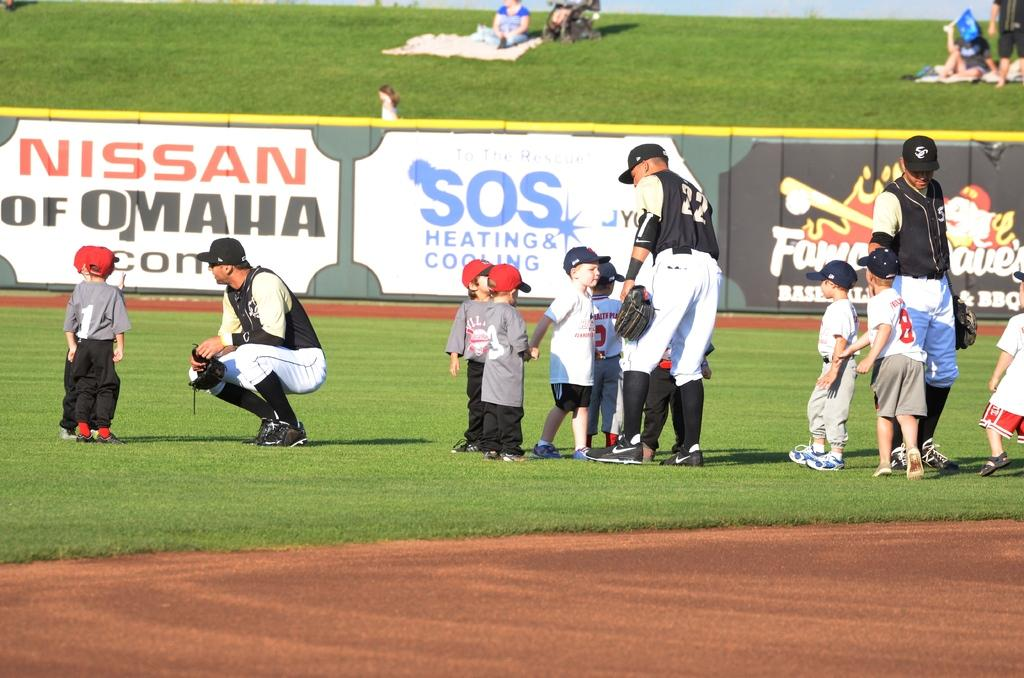<image>
Create a compact narrative representing the image presented. Youth ball players in front of a wall banner of SOS Heating & Cooling. 